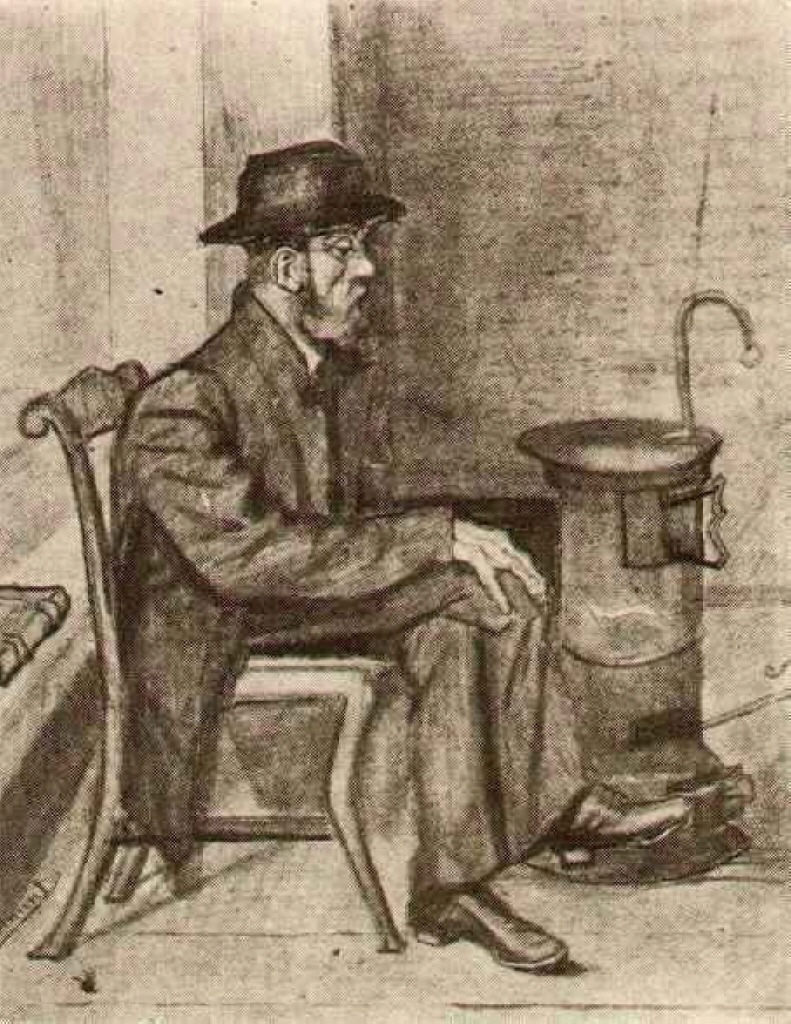If you could interact with the man in the image, what questions would you ask him, and why? If I could interact with him, I would ask, 'What are the thoughts that occupy your mind in this quiet moment?' Understanding his inner thoughts would offer deeper insights into his personal experiences and emotional state. Additionally, I might ask, 'What stories does this old stove hold for you?' Such a question could reveal the history and significance of the stove in his life, perhaps uncovering memories associated with warmth and family. What kind of future might this man envisage for himself considering the era he lives in? Considering the era he lives in, this man might envisage a future fraught with both challenges and hopes. He might aspire for a stable livelihood, dreaming of better opportunities for his family. Given the industrial backdrop of his time, he might hope for advancements in society that could offer easier, more comfortable living conditions. However, he is also likely aware of the societal struggles and economic uncertainties that could shape his future, reflecting a balance of cautious hope and pragmatic realism. 